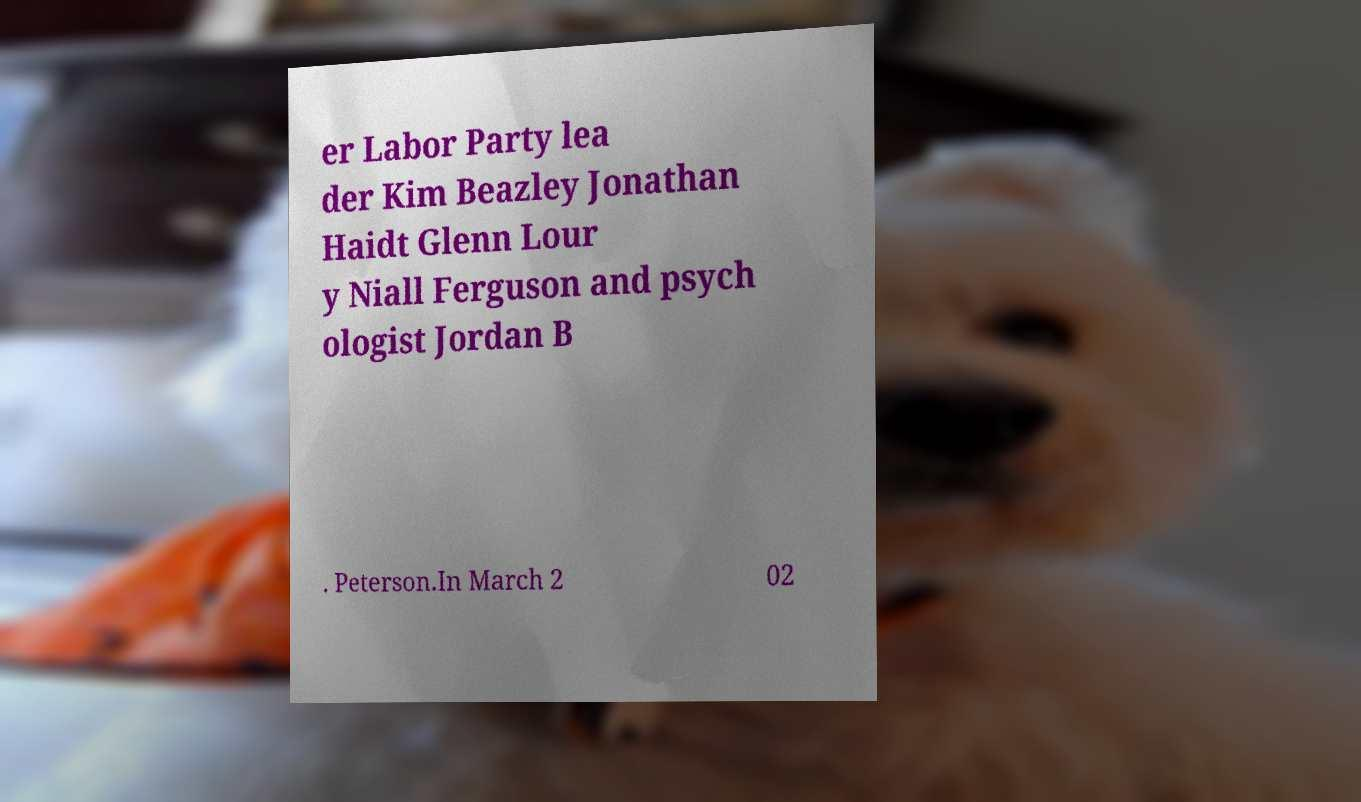Please read and relay the text visible in this image. What does it say? er Labor Party lea der Kim Beazley Jonathan Haidt Glenn Lour y Niall Ferguson and psych ologist Jordan B . Peterson.In March 2 02 